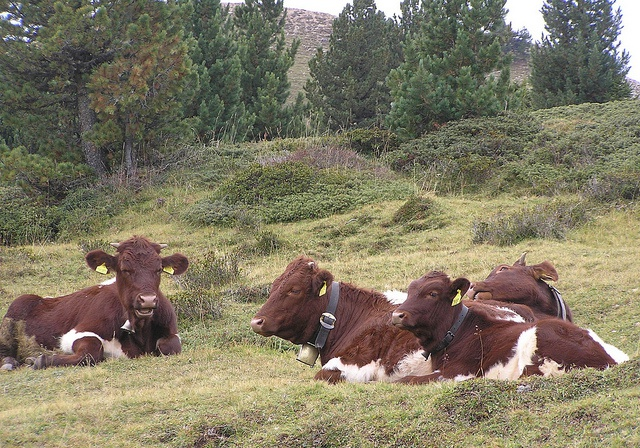Describe the objects in this image and their specific colors. I can see cow in gray, brown, maroon, and black tones, cow in gray, maroon, brown, black, and white tones, cow in gray, maroon, brown, and black tones, and cow in gray, brown, maroon, and black tones in this image. 